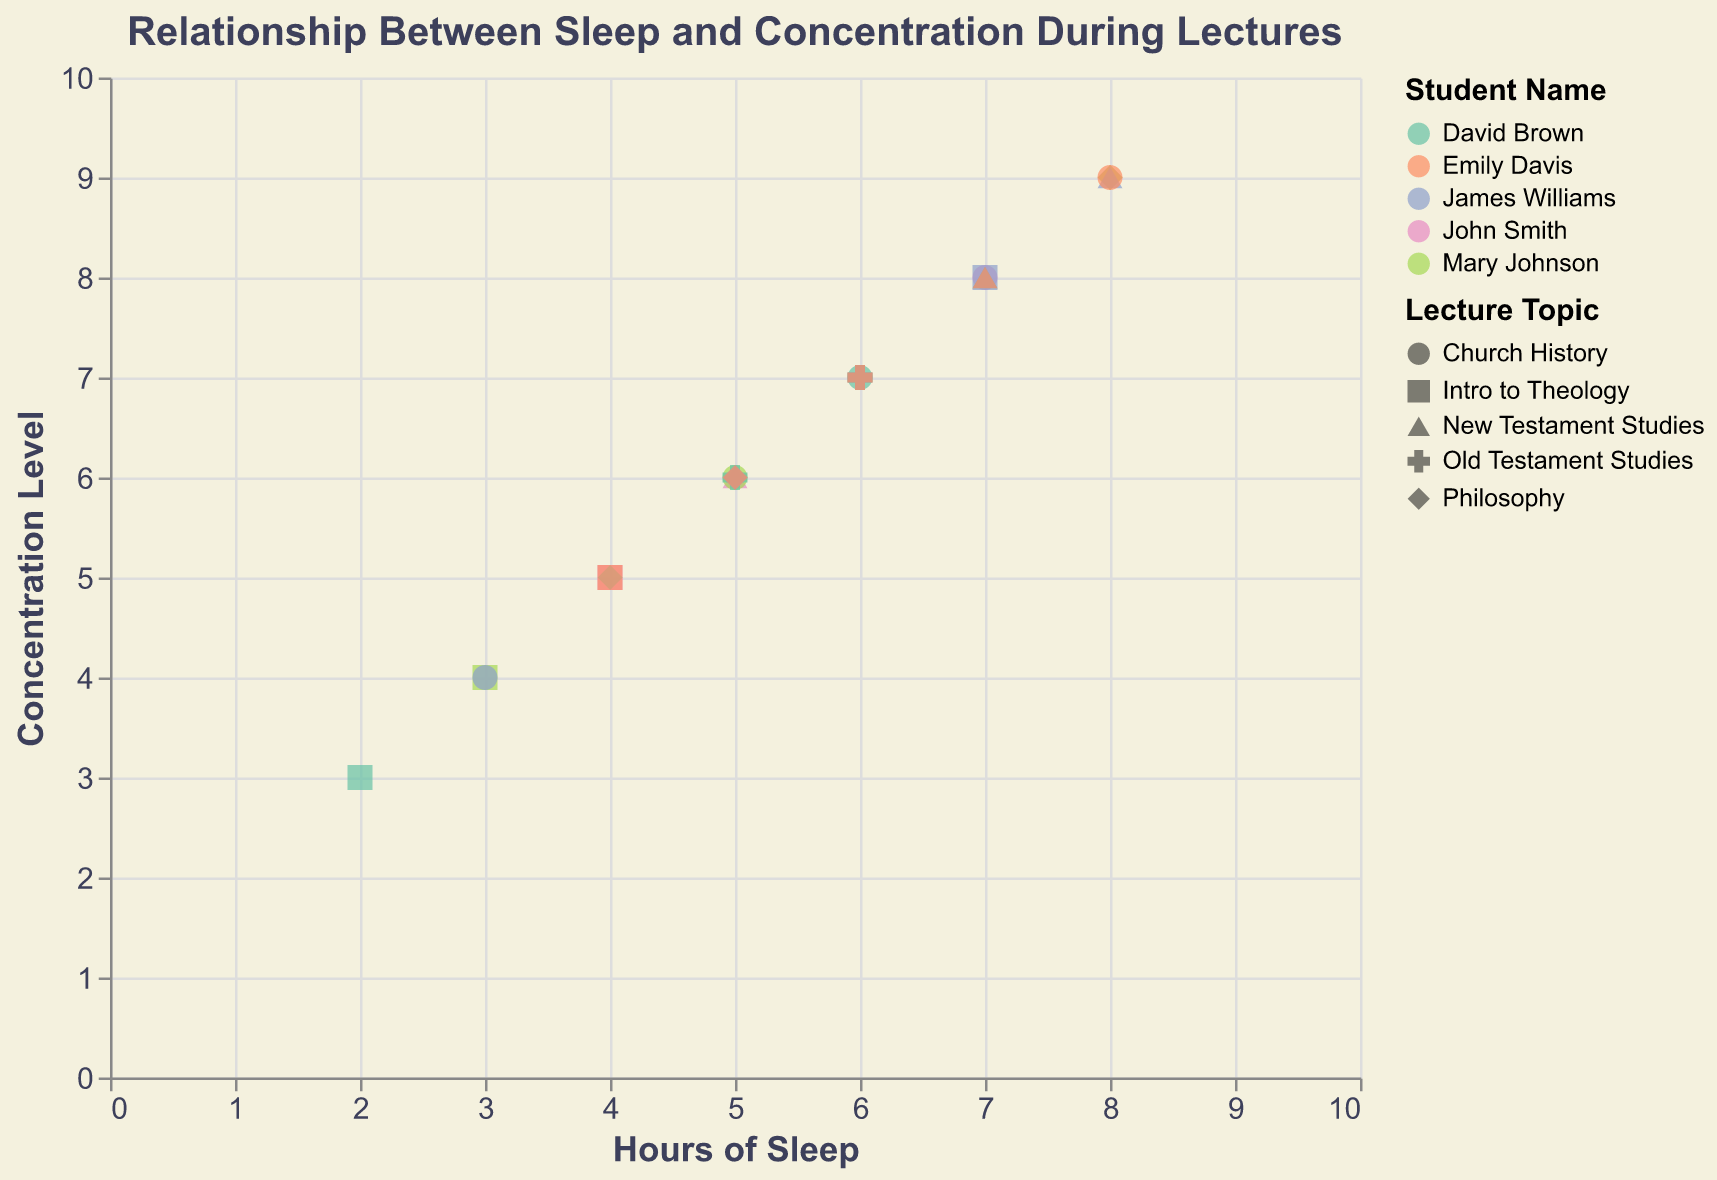What's the title of the figure? The title is usually at the top of the chart, emphasizing the main insight of the plotted data. Here, you can see it in bold: "Relationship Between Sleep and Concentration During Lectures".
Answer: Relationship Between Sleep and Concentration During Lectures How many students are represented in the figure? Count the unique names listed under the "Student Name" legend on the right side of the chart. The students names are John Smith, Mary Johnson, David Brown, James Williams, and Emily Davis.
Answer: 5 Which student has the highest concentration level for any given lecture? Look for the highest y-axis value, which corresponds to concentration levels, and check which student's data point is at that level. The highest concentration value is 9, seen multiple times, so checking the students is needed. For Philosophy lecture, John Smith, Mary Johnson, and James Williams all have a concentration level of 9.
Answer: John Smith, Mary Johnson, and James Williams Which lecture topics have generally higher concentration levels? Identify the shapes that show up more frequently in the upper part of the y-axis. Topics like Philosophy and New Testament Studies often have concentration levels of 8 or 9.
Answer: Philosophy and New Testament Studies What is the relationship between amount of sleep and concentration level? Observe the trend of the scatter points. As the x-axis values (hours of sleep) increase, the y-axis values (concentration levels) generally increase as well. This indicates a positive correlation between sleep and concentration.
Answer: Positive correlation What is the average concentration level for lectures where students had 7 hours of sleep? Identify all data points where "sleep_hours" is 7, then average their "concentration_level" values: John Smith (8), Mary Johnson (8), David Brown (8), Emily Davis (8). Sum = 8 + 8 + 8 + 8 = 32, average = 32 / 4 = 8.
Answer: 8 Who has the most varied concentration levels across different lectures and what is the range? Check the range of concentration values for each student by finding the maximum and minimum values. For example, John Smith's range is from 5 to 9, Mary Johnson's is from 4 to 9, David Brown's is from 3 to 8, James Williams's is from 4 to 9, and Emily Davis's is from 5 to 9. David Brown has the most varied concentration levels with a range of 8 - 3 = 5.
Answer: David Brown, Range: 5 Which lecture topic did John Smith show the least concentration in? Look for John Smith's data points and identify which one has the lowest y-axis value. The lowest concentration level for John Smith is 5 in Intro to Theology.
Answer: Intro to Theology Do any students have identical concentration levels for the same lecture topic? Look for overlapping data points in terms of concentration level (y-axis) and lecture topic (shape). For instance, both John Smith and Emily Davis have a concentration level of 6 for Church History.
Answer: Yes, John Smith and Emily Davis for Church History 